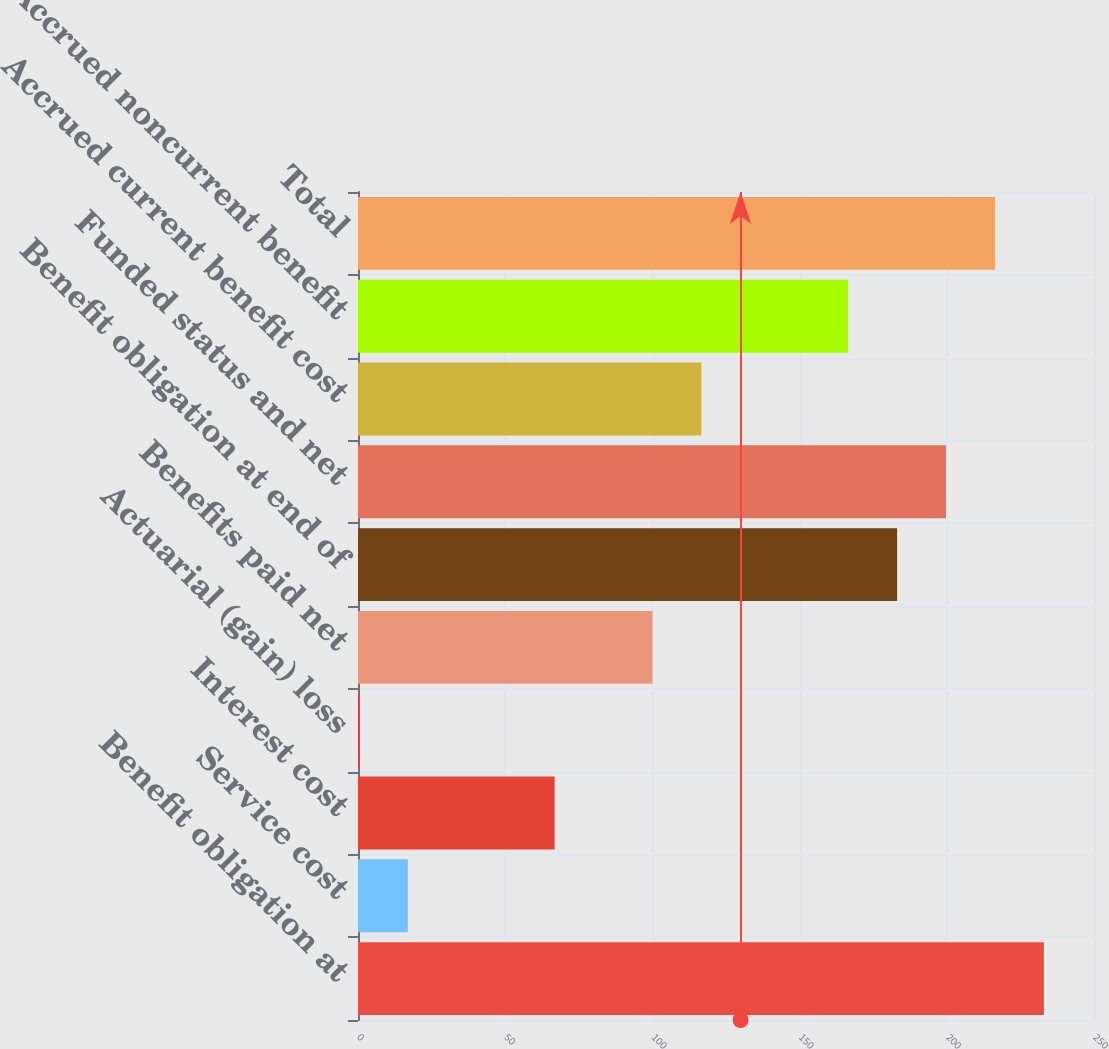Convert chart. <chart><loc_0><loc_0><loc_500><loc_500><bar_chart><fcel>Benefit obligation at<fcel>Service cost<fcel>Interest cost<fcel>Actuarial (gain) loss<fcel>Benefits paid net<fcel>Benefit obligation at end of<fcel>Funded status and net<fcel>Accrued current benefit cost<fcel>Accrued noncurrent benefit<fcel>Total<nl><fcel>232.98<fcel>16.92<fcel>66.78<fcel>0.3<fcel>100.02<fcel>183.12<fcel>199.74<fcel>116.64<fcel>166.5<fcel>216.36<nl></chart> 